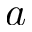<formula> <loc_0><loc_0><loc_500><loc_500>a</formula> 